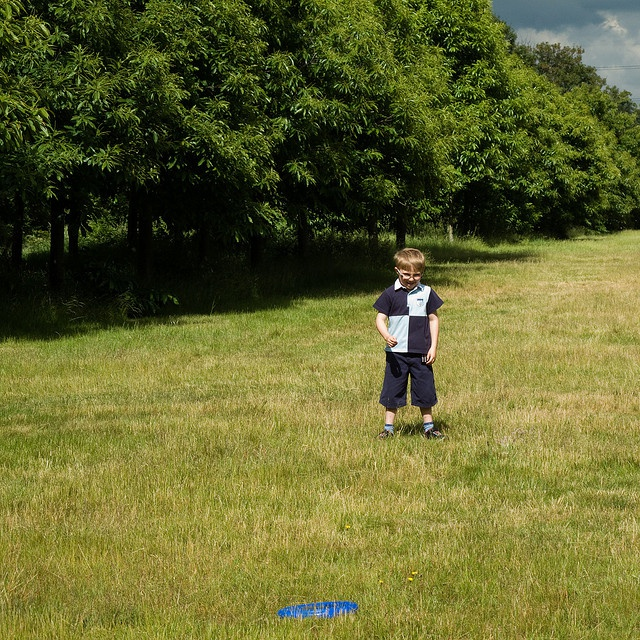Describe the objects in this image and their specific colors. I can see people in olive, black, lightgray, and tan tones and frisbee in olive, blue, and gray tones in this image. 